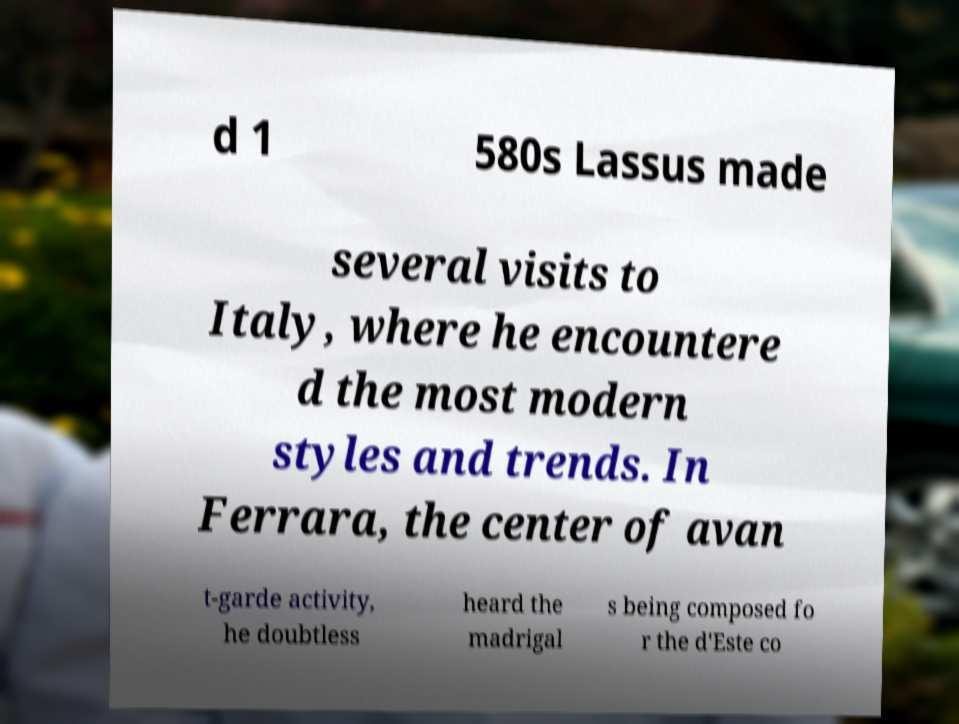There's text embedded in this image that I need extracted. Can you transcribe it verbatim? d 1 580s Lassus made several visits to Italy, where he encountere d the most modern styles and trends. In Ferrara, the center of avan t-garde activity, he doubtless heard the madrigal s being composed fo r the d'Este co 